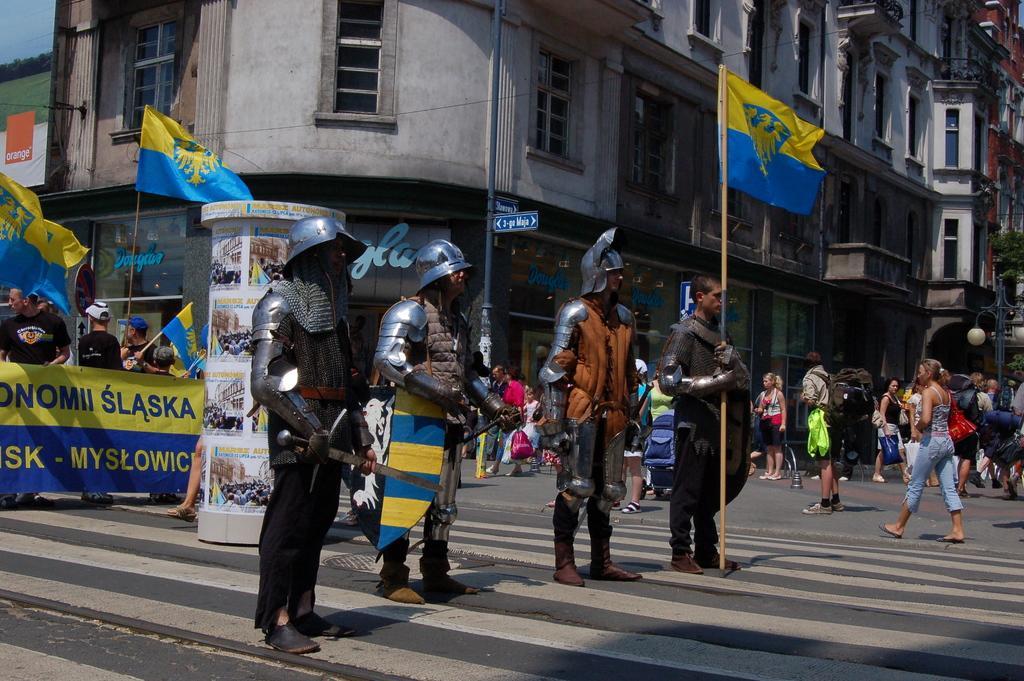In one or two sentences, can you explain what this image depicts? In this image there are four people holding the flag, knife and a few other objects. Behind them there are a few other people holding the flags and banners. There is a pillar. On the right side of the image there are a few people standing on the road. In the background of the image there are buildings, trees, light poles. There is a directional board. 